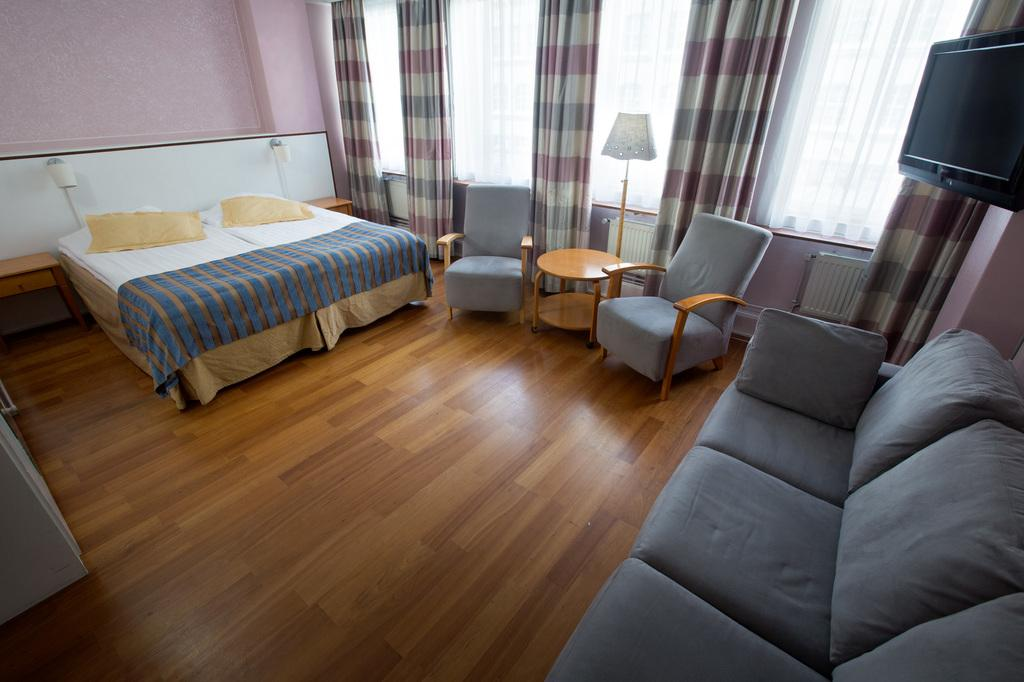What type of furniture is present in the image? There is a bed, 2 tables, 2 chairs, a sofa, and a lamp in the image. What can be used for lighting in the image? There is a lamp in the image for lighting. What type of window treatment is present in the image? There are curtains in the image. What type of entertainment device is present in the image? There is a TV in the image. What color is the wall in the image? The wall has a pink color. Can you see any animals from the zoo in the image? No, there are no animals from the zoo present in the image. How many houses are visible in the image? There is only one house visible in the image, which is the room being depicted. 